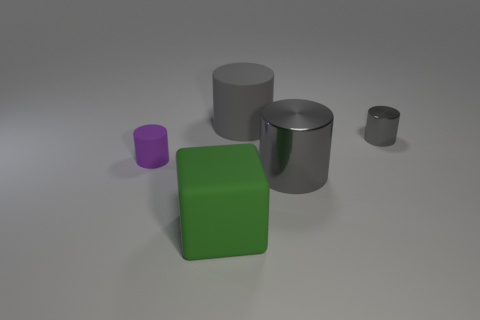Subtract all brown blocks. How many gray cylinders are left? 3 Subtract all gray cylinders. Subtract all brown spheres. How many cylinders are left? 1 Add 1 gray rubber cylinders. How many objects exist? 6 Subtract all cylinders. How many objects are left? 1 Add 2 small purple matte cylinders. How many small purple matte cylinders exist? 3 Subtract 0 gray blocks. How many objects are left? 5 Subtract all small green cylinders. Subtract all green matte objects. How many objects are left? 4 Add 4 small purple rubber cylinders. How many small purple rubber cylinders are left? 5 